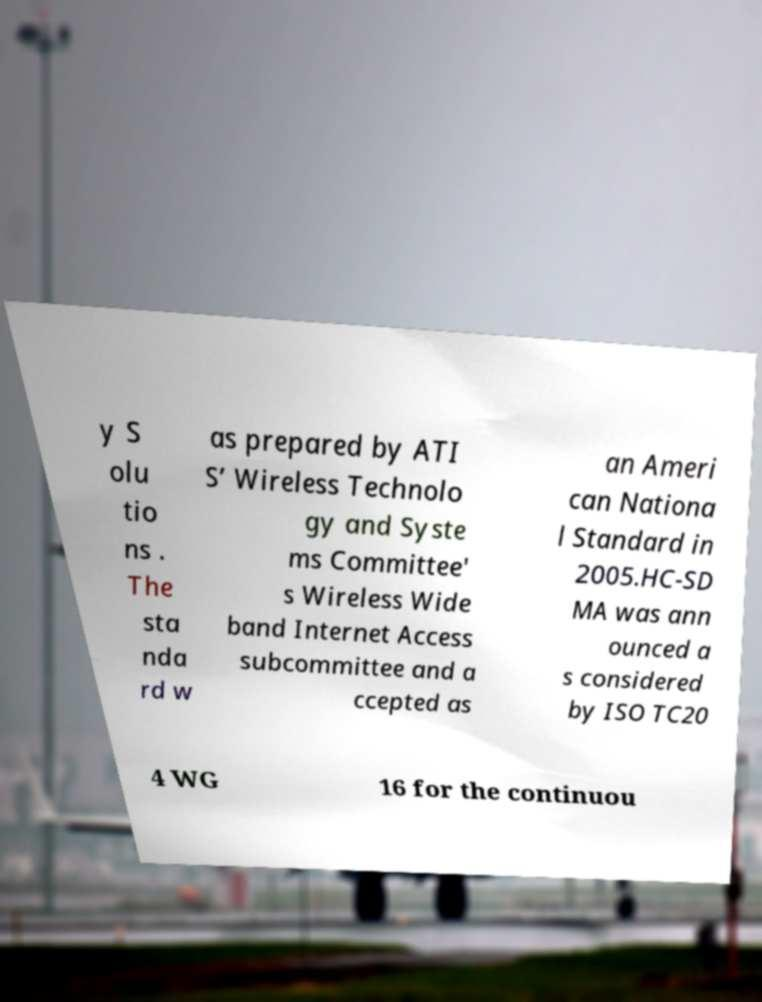Can you read and provide the text displayed in the image?This photo seems to have some interesting text. Can you extract and type it out for me? y S olu tio ns . The sta nda rd w as prepared by ATI S’ Wireless Technolo gy and Syste ms Committee' s Wireless Wide band Internet Access subcommittee and a ccepted as an Ameri can Nationa l Standard in 2005.HC-SD MA was ann ounced a s considered by ISO TC20 4 WG 16 for the continuou 